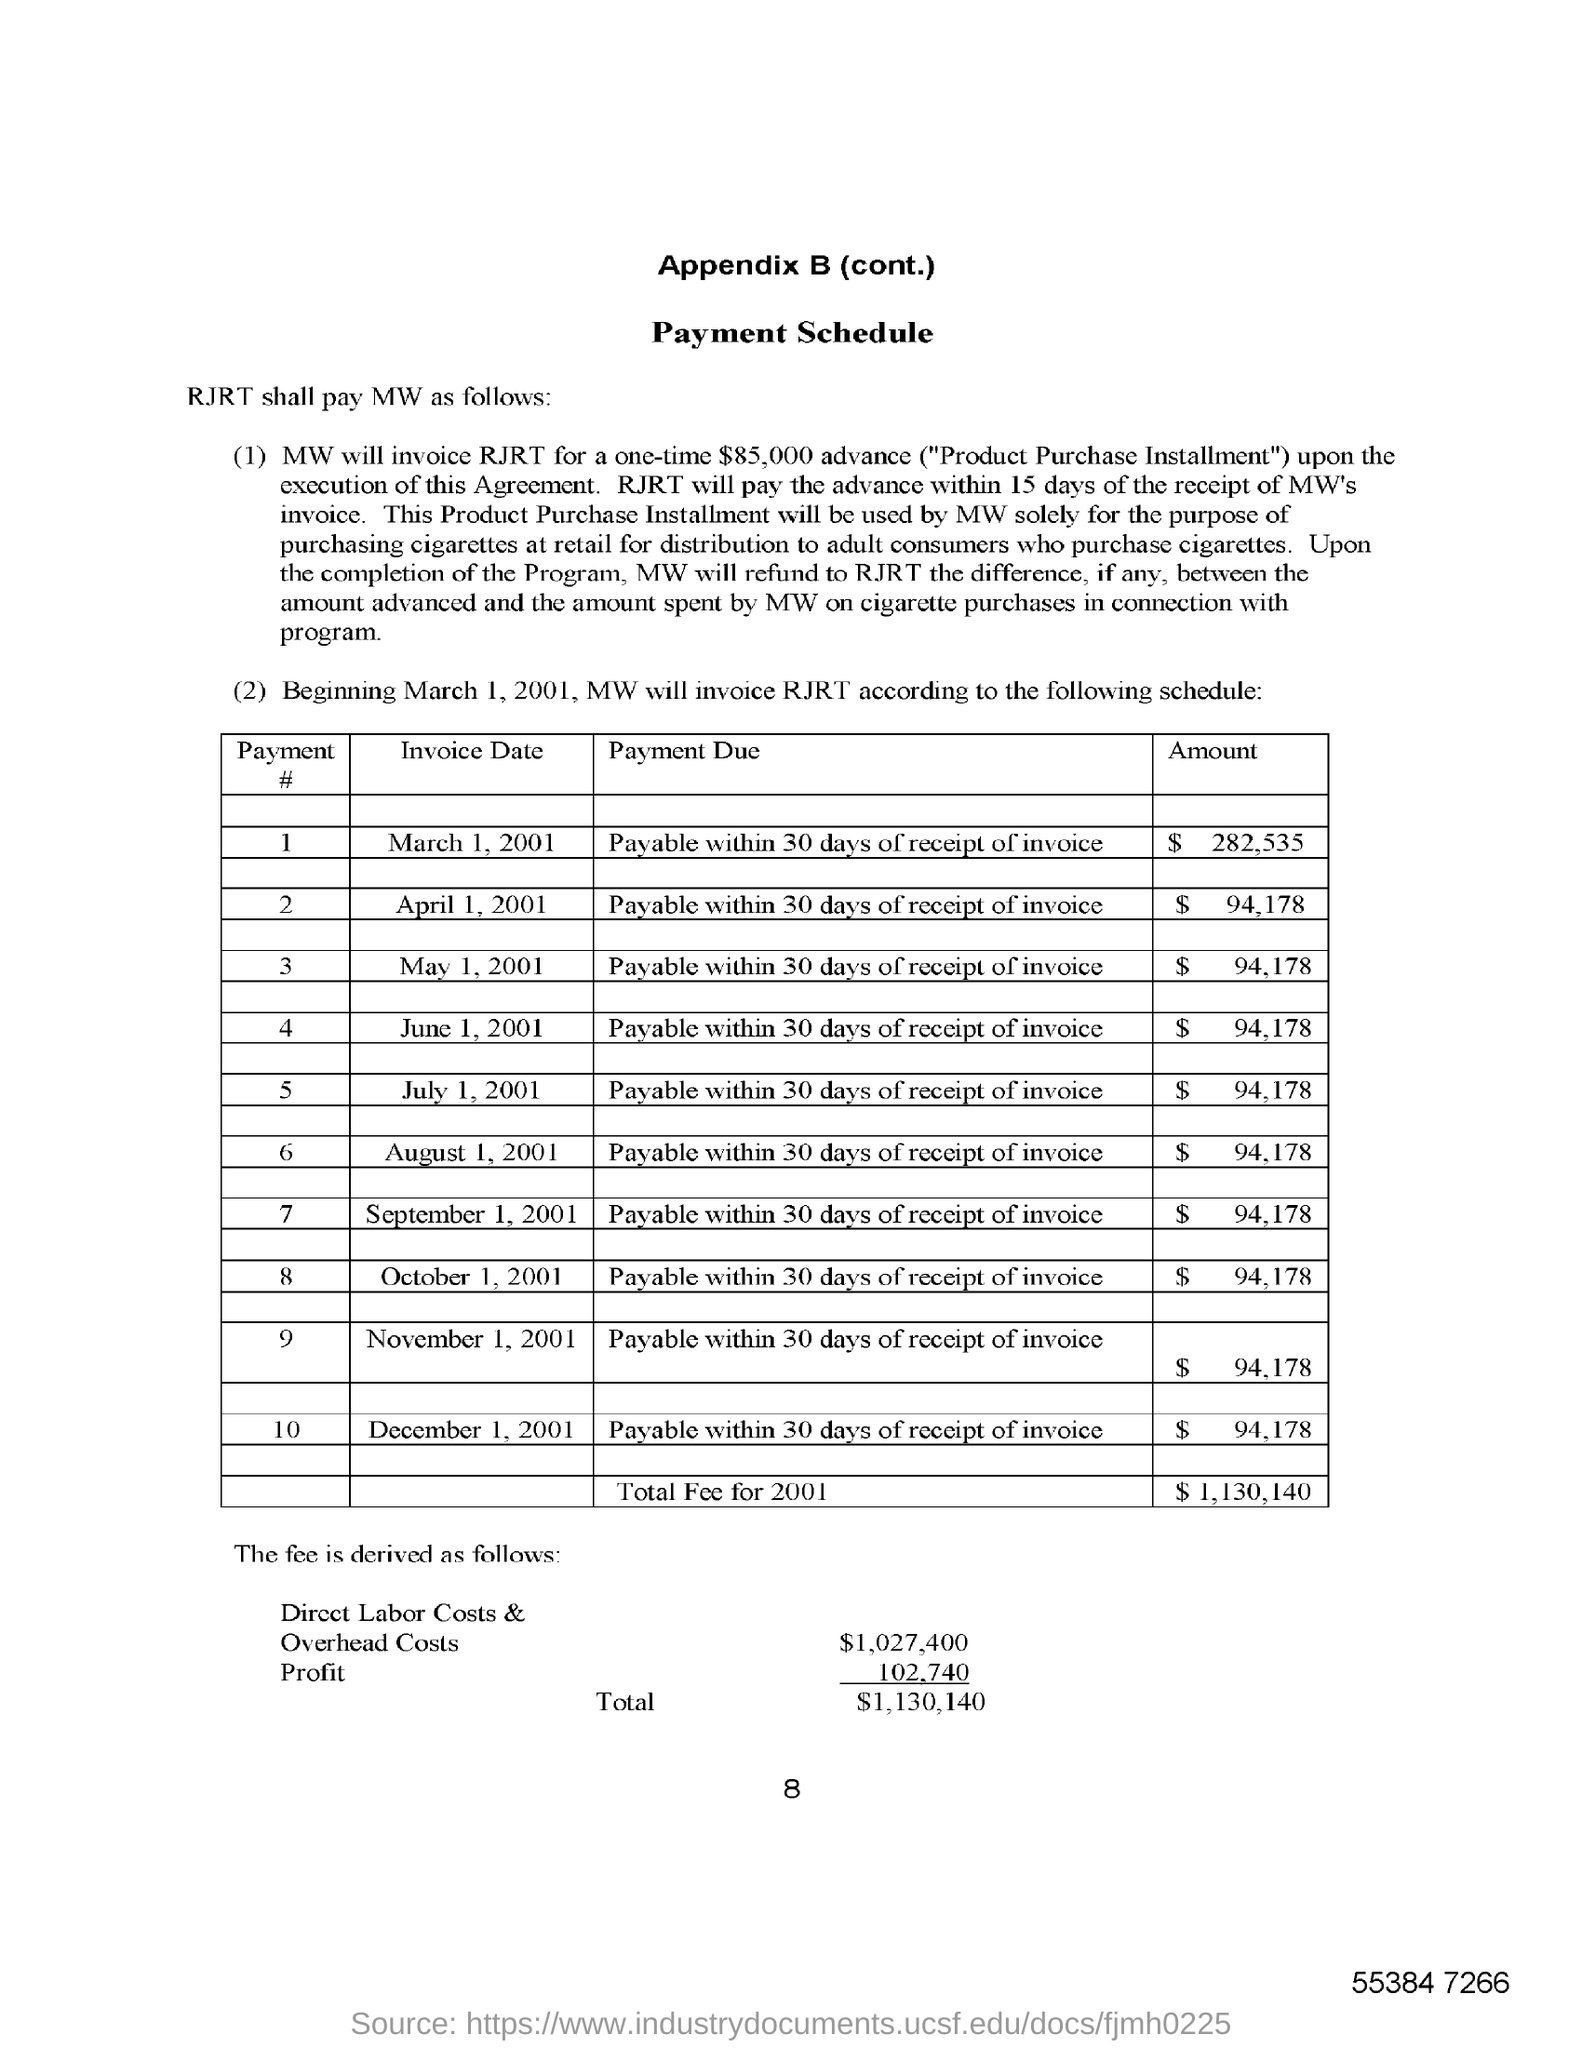What is the Direct Labor Costs & Overhead Costs?
Provide a succinct answer. $1,027,400. 